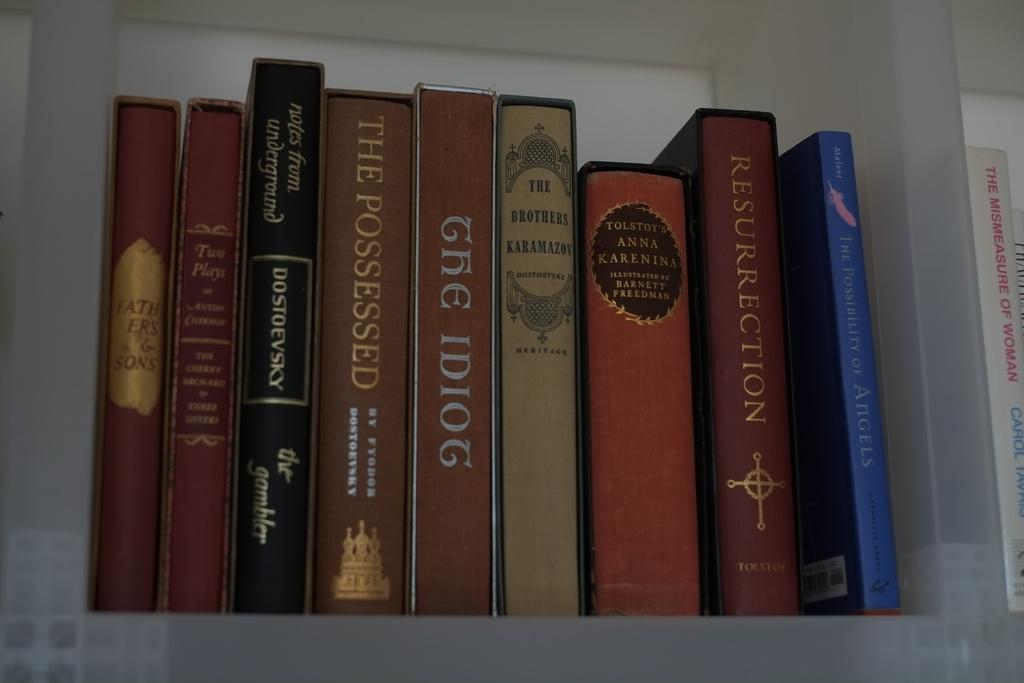<image>
Provide a brief description of the given image. The Possessed is one of 9 books sitting on a shelf. 